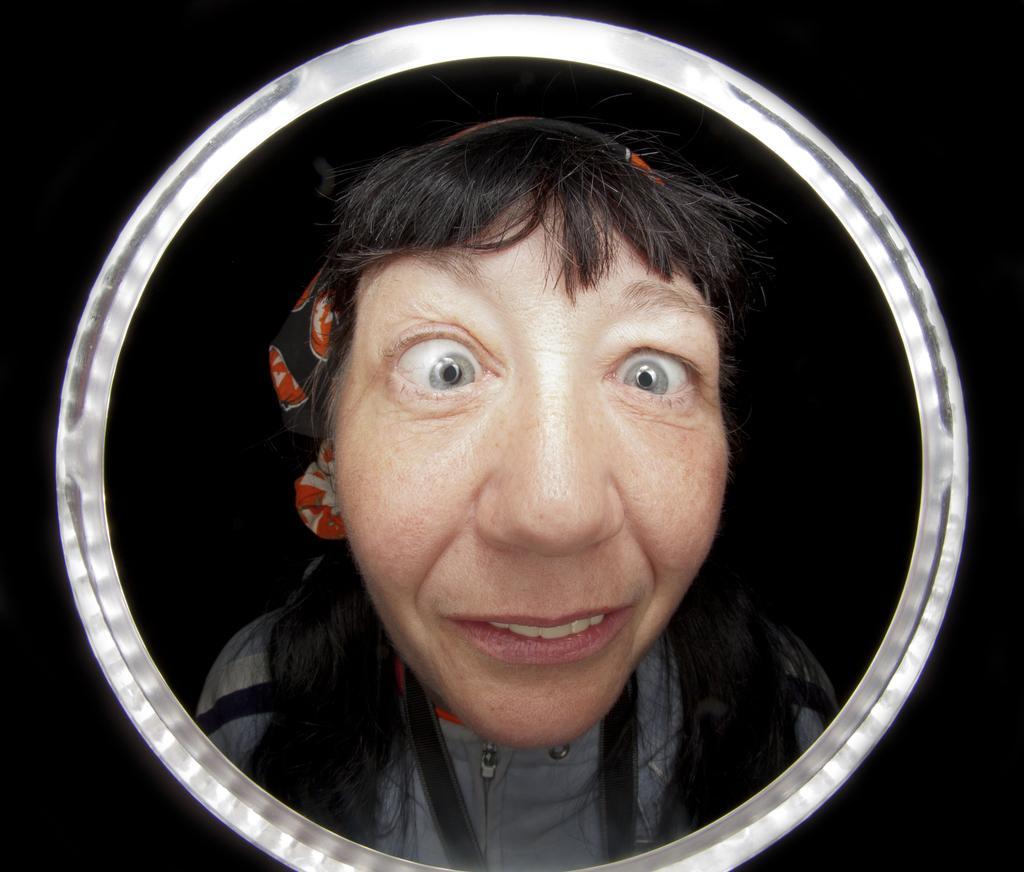Can you describe this image briefly? In this image, we can see there is a circular object. Through this object, there is a woman in a blue color jacket, smiling and watching something. And the background is dark in color. 